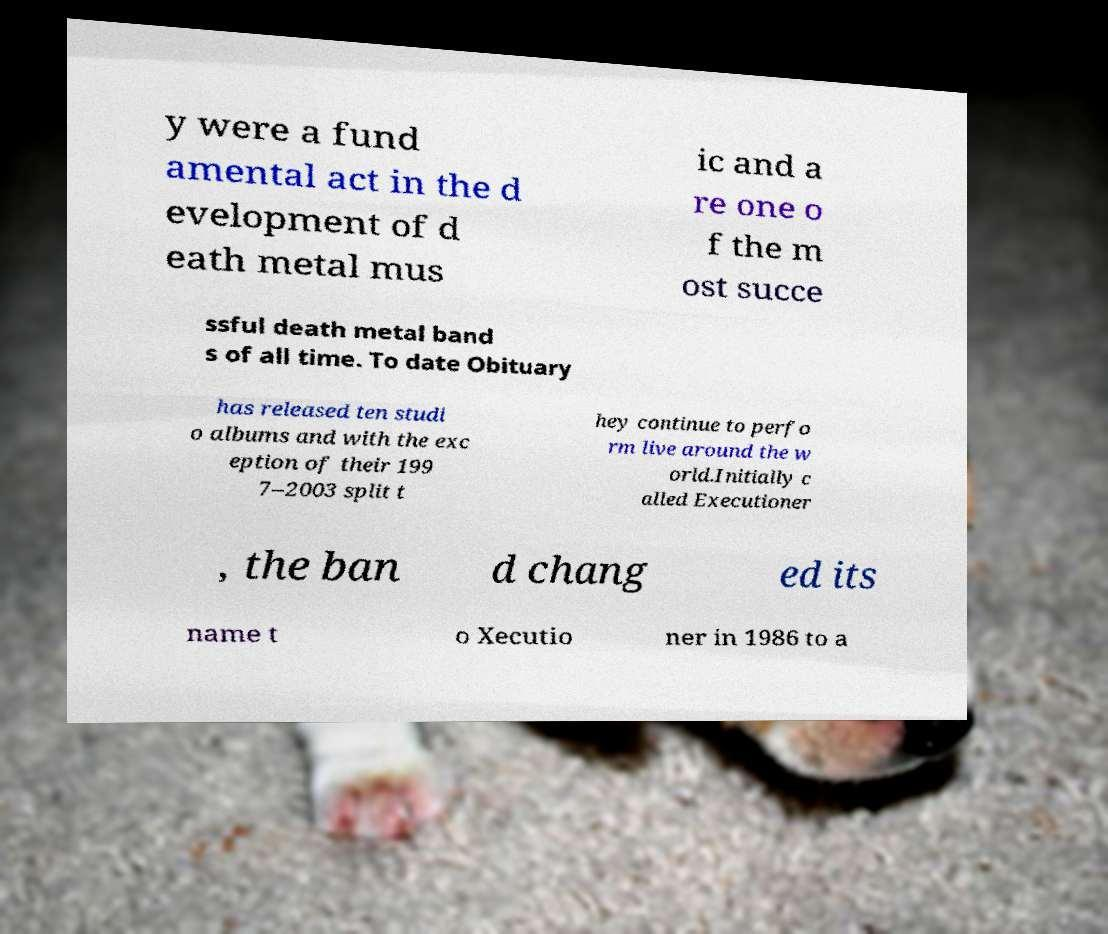I need the written content from this picture converted into text. Can you do that? y were a fund amental act in the d evelopment of d eath metal mus ic and a re one o f the m ost succe ssful death metal band s of all time. To date Obituary has released ten studi o albums and with the exc eption of their 199 7–2003 split t hey continue to perfo rm live around the w orld.Initially c alled Executioner , the ban d chang ed its name t o Xecutio ner in 1986 to a 